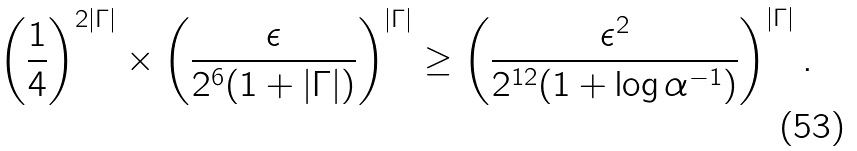<formula> <loc_0><loc_0><loc_500><loc_500>\left ( \frac { 1 } { 4 } \right ) ^ { 2 | \Gamma | } \times \left ( \frac { \epsilon } { 2 ^ { 6 } ( 1 + | \Gamma | ) } \right ) ^ { | \Gamma | } \geq \left ( \frac { \epsilon ^ { 2 } } { 2 ^ { 1 2 } ( 1 + \log \alpha ^ { - 1 } ) } \right ) ^ { | \Gamma | } .</formula> 